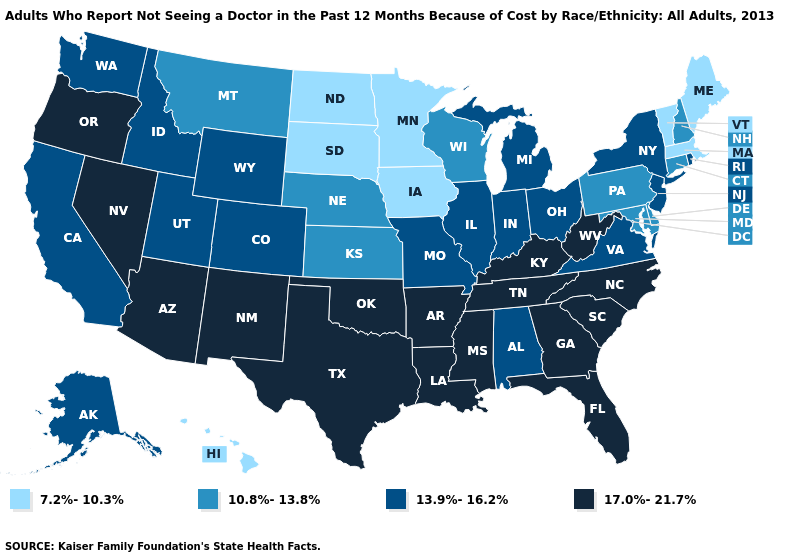Name the states that have a value in the range 10.8%-13.8%?
Answer briefly. Connecticut, Delaware, Kansas, Maryland, Montana, Nebraska, New Hampshire, Pennsylvania, Wisconsin. Name the states that have a value in the range 17.0%-21.7%?
Quick response, please. Arizona, Arkansas, Florida, Georgia, Kentucky, Louisiana, Mississippi, Nevada, New Mexico, North Carolina, Oklahoma, Oregon, South Carolina, Tennessee, Texas, West Virginia. What is the highest value in the MidWest ?
Concise answer only. 13.9%-16.2%. Name the states that have a value in the range 10.8%-13.8%?
Short answer required. Connecticut, Delaware, Kansas, Maryland, Montana, Nebraska, New Hampshire, Pennsylvania, Wisconsin. Name the states that have a value in the range 10.8%-13.8%?
Short answer required. Connecticut, Delaware, Kansas, Maryland, Montana, Nebraska, New Hampshire, Pennsylvania, Wisconsin. Which states have the lowest value in the USA?
Short answer required. Hawaii, Iowa, Maine, Massachusetts, Minnesota, North Dakota, South Dakota, Vermont. Name the states that have a value in the range 7.2%-10.3%?
Be succinct. Hawaii, Iowa, Maine, Massachusetts, Minnesota, North Dakota, South Dakota, Vermont. What is the highest value in the USA?
Quick response, please. 17.0%-21.7%. What is the value of Louisiana?
Keep it brief. 17.0%-21.7%. Does Hawaii have the lowest value in the West?
Concise answer only. Yes. What is the value of Colorado?
Write a very short answer. 13.9%-16.2%. Is the legend a continuous bar?
Answer briefly. No. Which states hav the highest value in the MidWest?
Be succinct. Illinois, Indiana, Michigan, Missouri, Ohio. Name the states that have a value in the range 17.0%-21.7%?
Keep it brief. Arizona, Arkansas, Florida, Georgia, Kentucky, Louisiana, Mississippi, Nevada, New Mexico, North Carolina, Oklahoma, Oregon, South Carolina, Tennessee, Texas, West Virginia. Among the states that border Georgia , which have the highest value?
Quick response, please. Florida, North Carolina, South Carolina, Tennessee. 